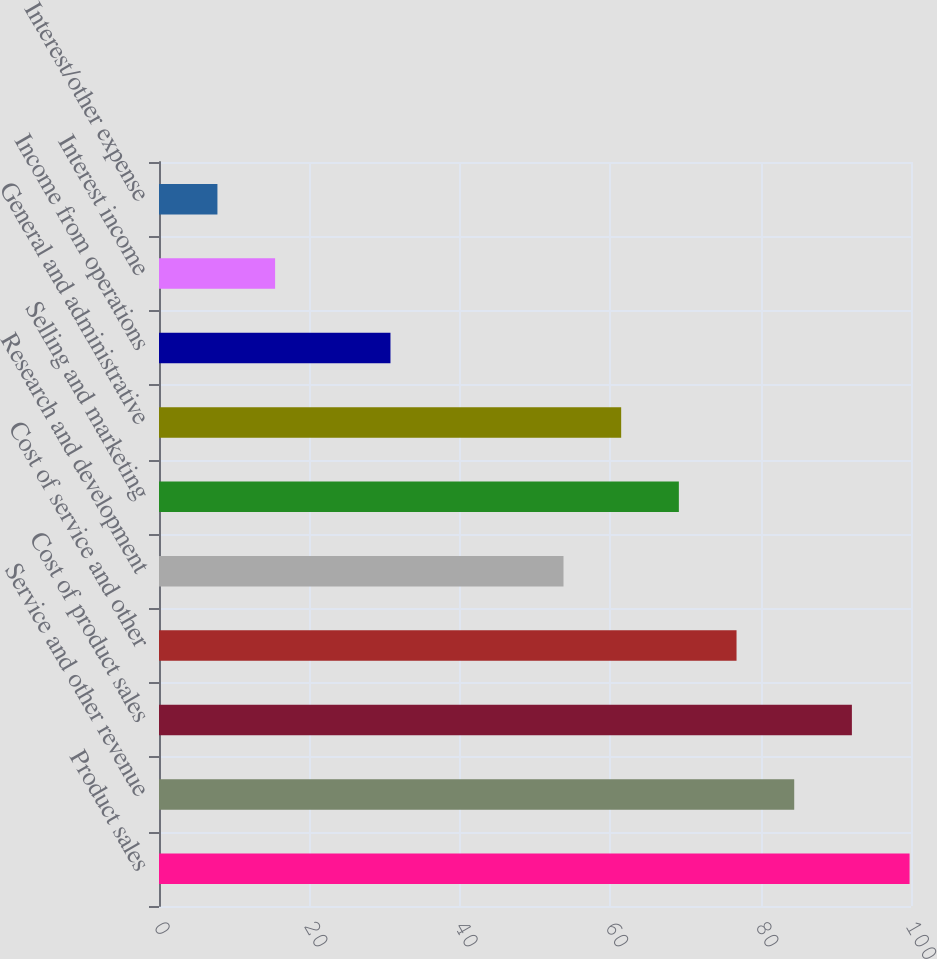Convert chart to OTSL. <chart><loc_0><loc_0><loc_500><loc_500><bar_chart><fcel>Product sales<fcel>Service and other revenue<fcel>Cost of product sales<fcel>Cost of service and other<fcel>Research and development<fcel>Selling and marketing<fcel>General and administrative<fcel>Income from operations<fcel>Interest income<fcel>Interest/other expense<nl><fcel>99.81<fcel>84.47<fcel>92.14<fcel>76.8<fcel>53.79<fcel>69.13<fcel>61.46<fcel>30.78<fcel>15.44<fcel>7.77<nl></chart> 